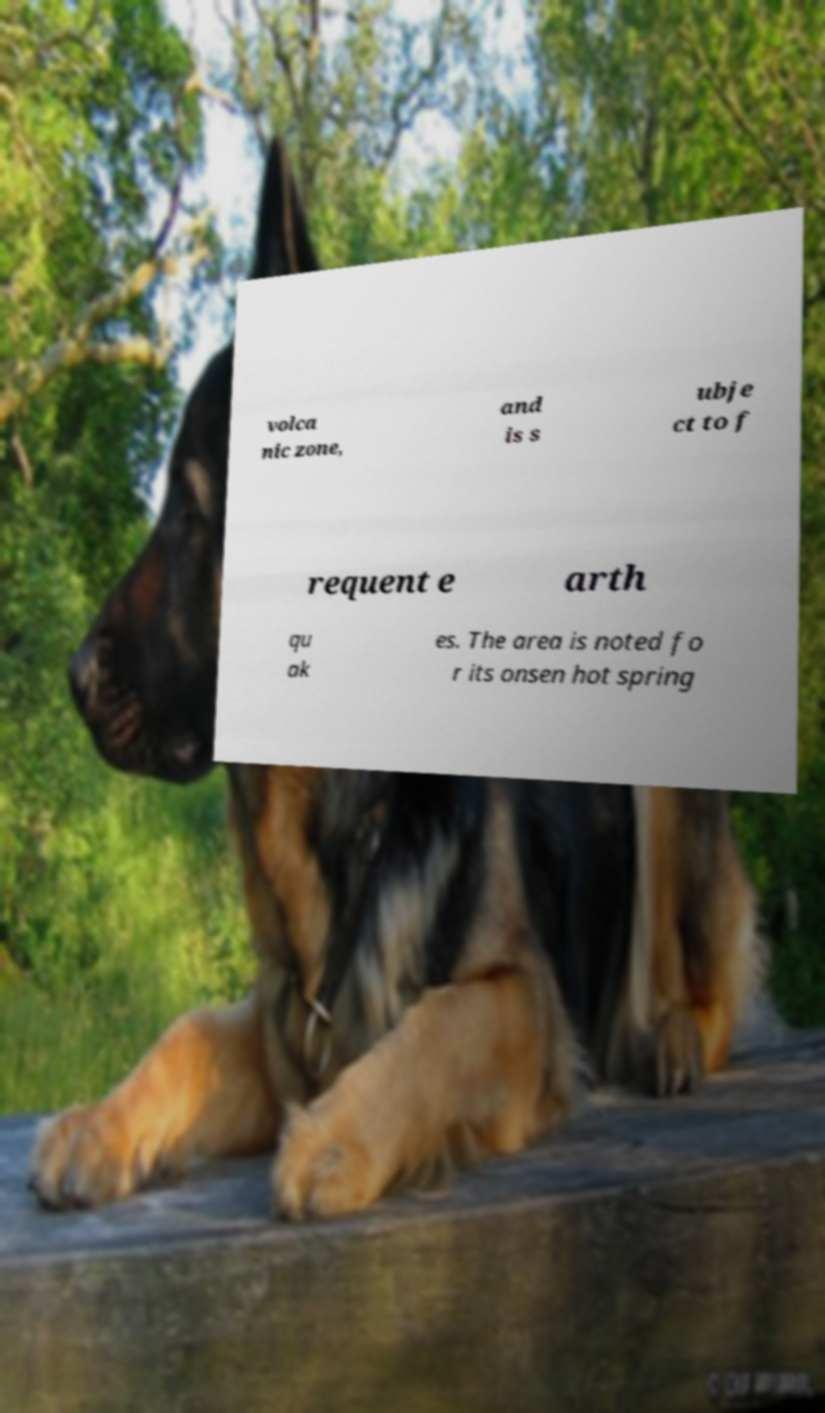Please read and relay the text visible in this image. What does it say? volca nic zone, and is s ubje ct to f requent e arth qu ak es. The area is noted fo r its onsen hot spring 